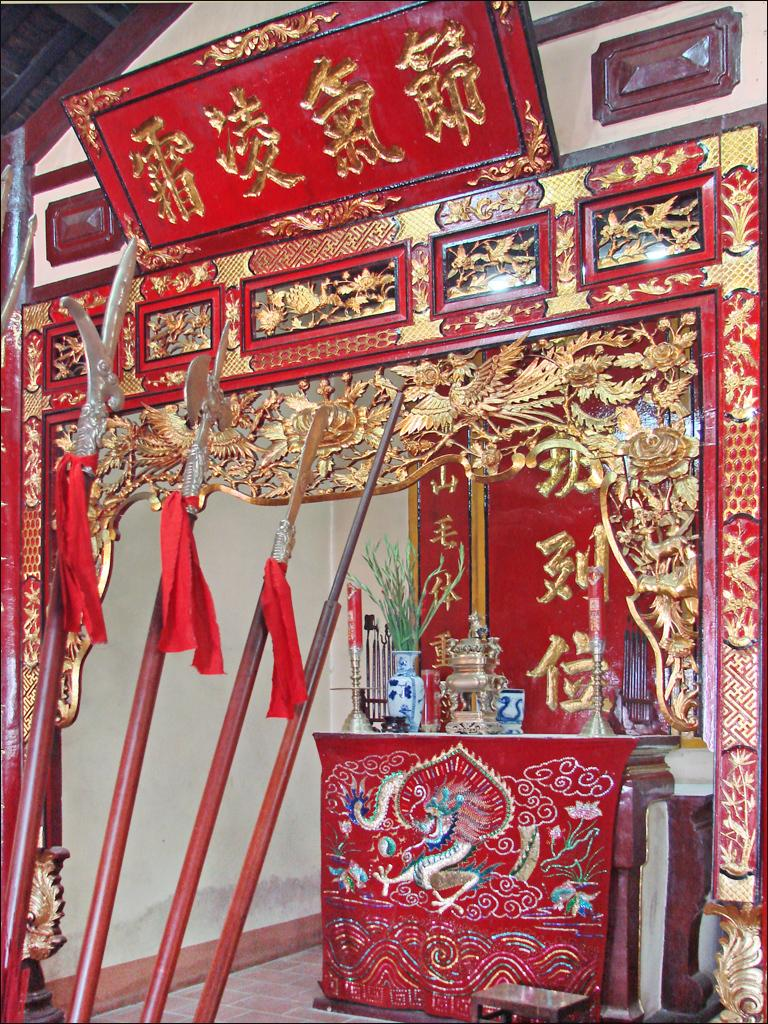What type of furniture is visible in the image? There is a table in the image. What is on the table? There are decorations on the table, including a candle holder and a candle. What is the purpose of the candle holder? The candle holder is used to hold a candle. What else can be seen in the image besides the table and its decorations? Weapons are present in the image, and they are tied with ribbons and placed on the floor. How much meat is being prepared on the table in the image? There is no meat present in the image; it features a table with decorations, a candle holder, a candle, and weapons tied with ribbons and placed on the floor. 